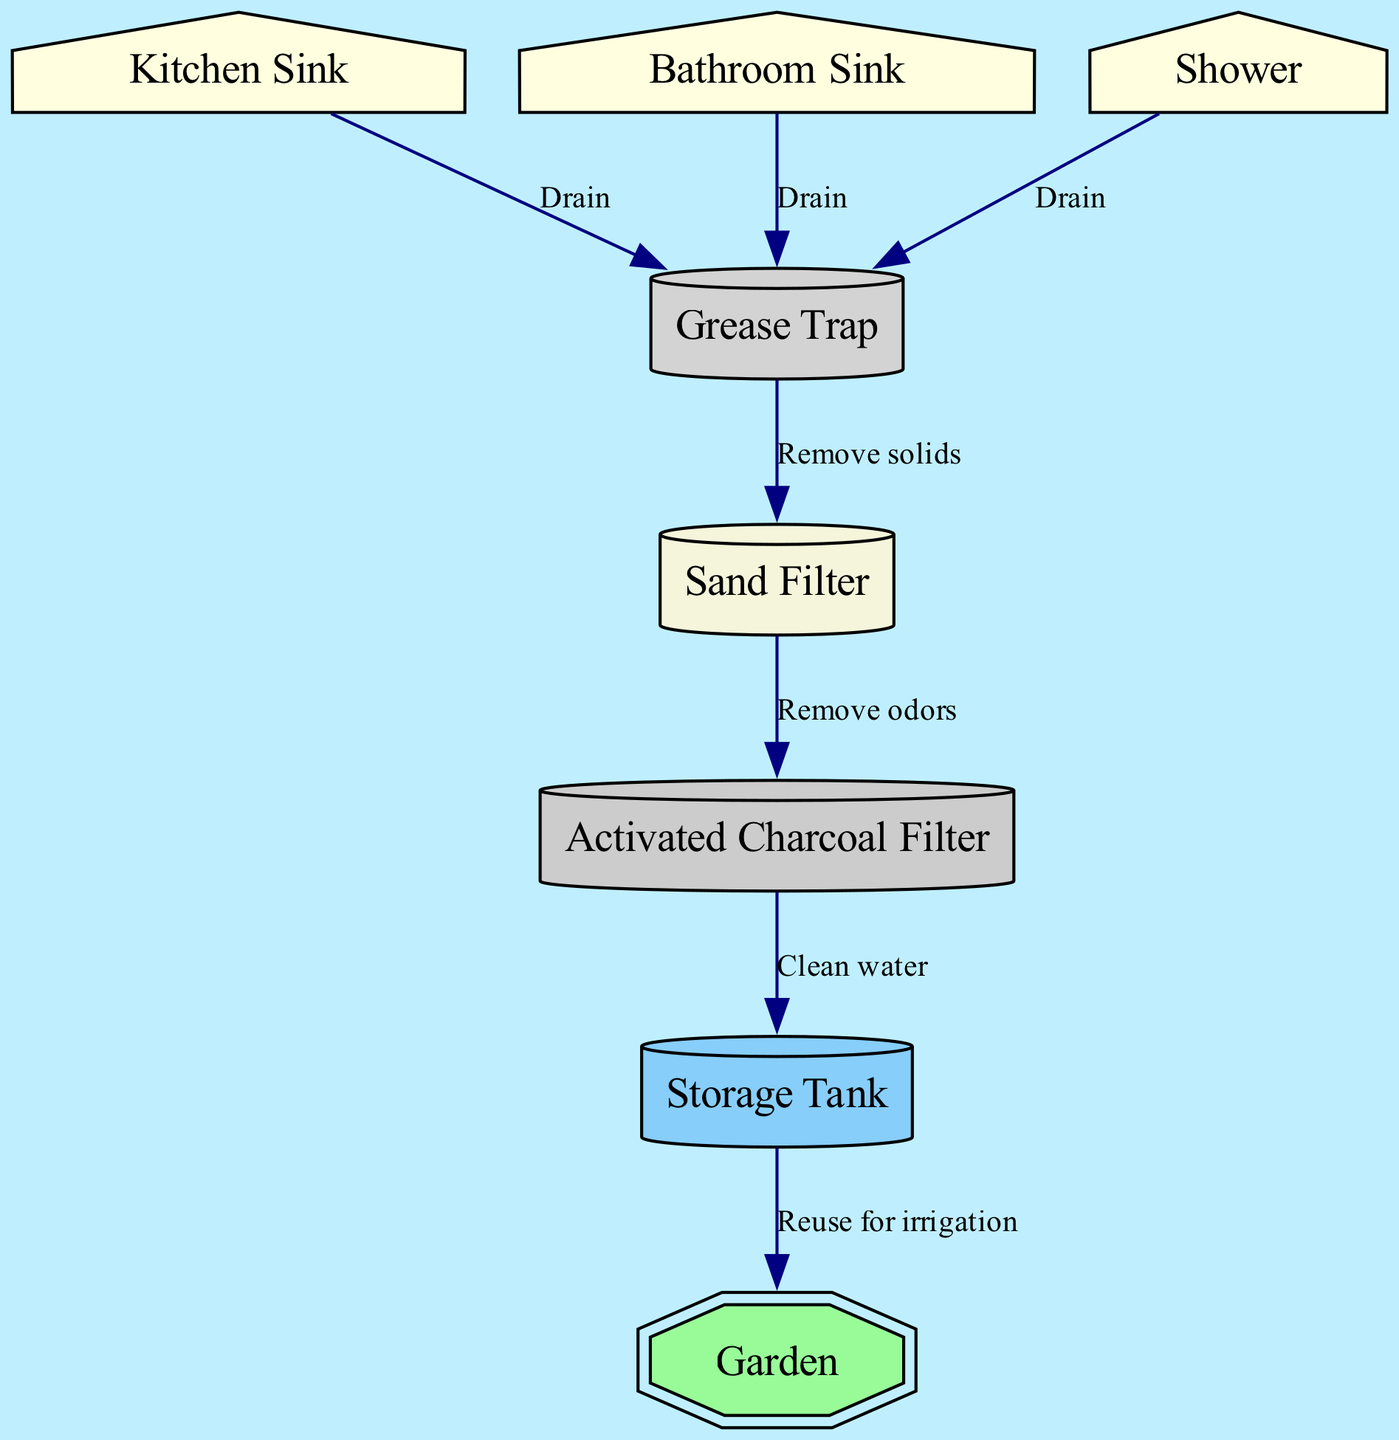What is the first node in the water flow? The first node in the water flow is the Kitchen Sink, as it is where the water enters the system before being directed to the Grease Trap.
Answer: Kitchen Sink How many nodes are there in the diagram? By counting each distinct labeled item (Kitchen Sink, Bathroom Sink, Shower, Grease Trap, Sand Filter, Activated Charcoal Filter, Storage Tank, Garden), we find that there are eight nodes in total.
Answer: 8 What is the function of the Grease Trap? The Grease Trap's function is to remove solids from the greywater before it is directed to the Sand Filter.
Answer: Remove solids Which two nodes are connected by the edge labeled "Clean water"? The edge labeled "Clean water" connects the Activated Charcoal Filter to the Storage Tank. This indicates that clean water flows into the Storage Tank after treatment.
Answer: Activated Charcoal Filter and Storage Tank What is the final destination of the treated greywater? The final destination of the treated greywater is the Garden, where it can be reused for irrigation after going through the entire treatment process.
Answer: Garden What node comes after the Sand Filter in the water flow? The node that comes after the Sand Filter is the Activated Charcoal Filter, indicating that further treatment occurs after the sand filtering process.
Answer: Activated Charcoal Filter How many drains are there leading into the Grease Trap? There are three drains leading into the Grease Trap, one from each of the Kitchen Sink, Bathroom Sink, and Shower.
Answer: 3 What is the purpose of the Activated Charcoal Filter? The purpose of the Activated Charcoal Filter is to remove odors from the greywater before it reaches the Storage Tank.
Answer: Remove odors 